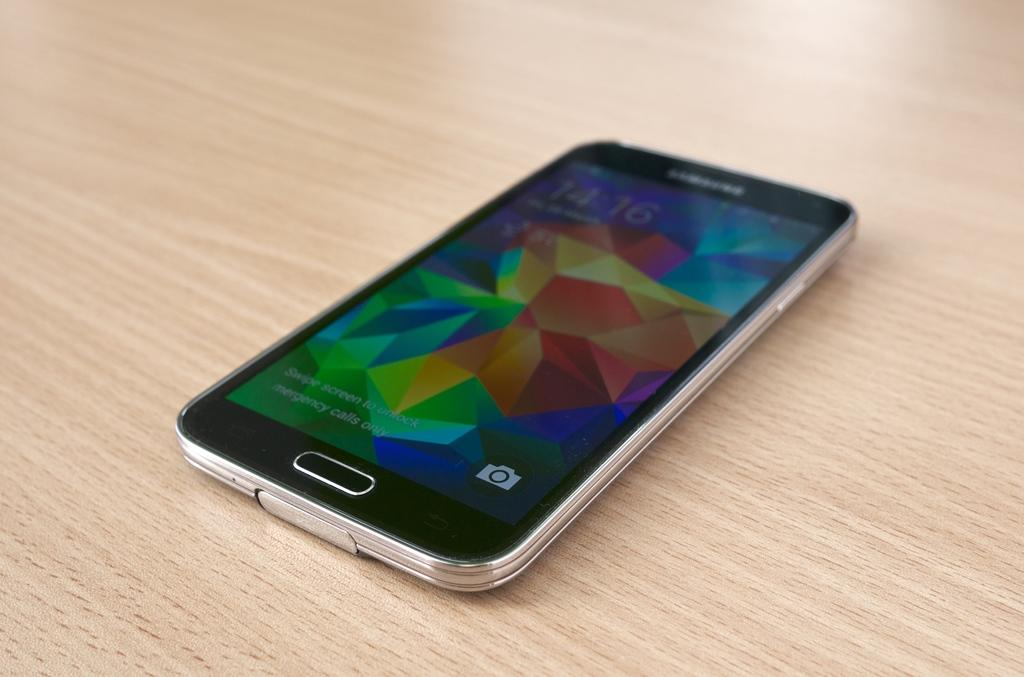<image>
Describe the image concisely. A samsung phone is sitting on the wooden surface at 14:16, or 2:16pm 